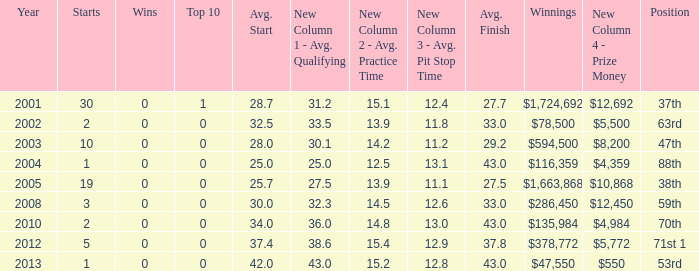How many starts for an average finish greater than 43? None. 